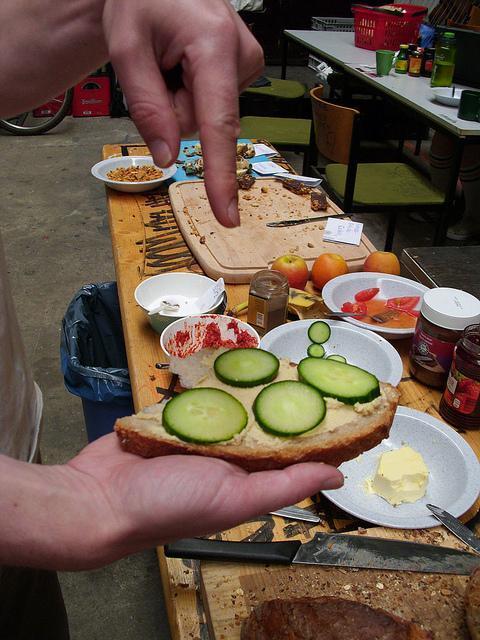How many knives on the table?
Give a very brief answer. 3. How many bottles can be seen?
Give a very brief answer. 2. How many dining tables can you see?
Give a very brief answer. 2. How many sandwiches are in the photo?
Give a very brief answer. 1. How many bowls are there?
Give a very brief answer. 6. How many dogs in the picture?
Give a very brief answer. 0. 